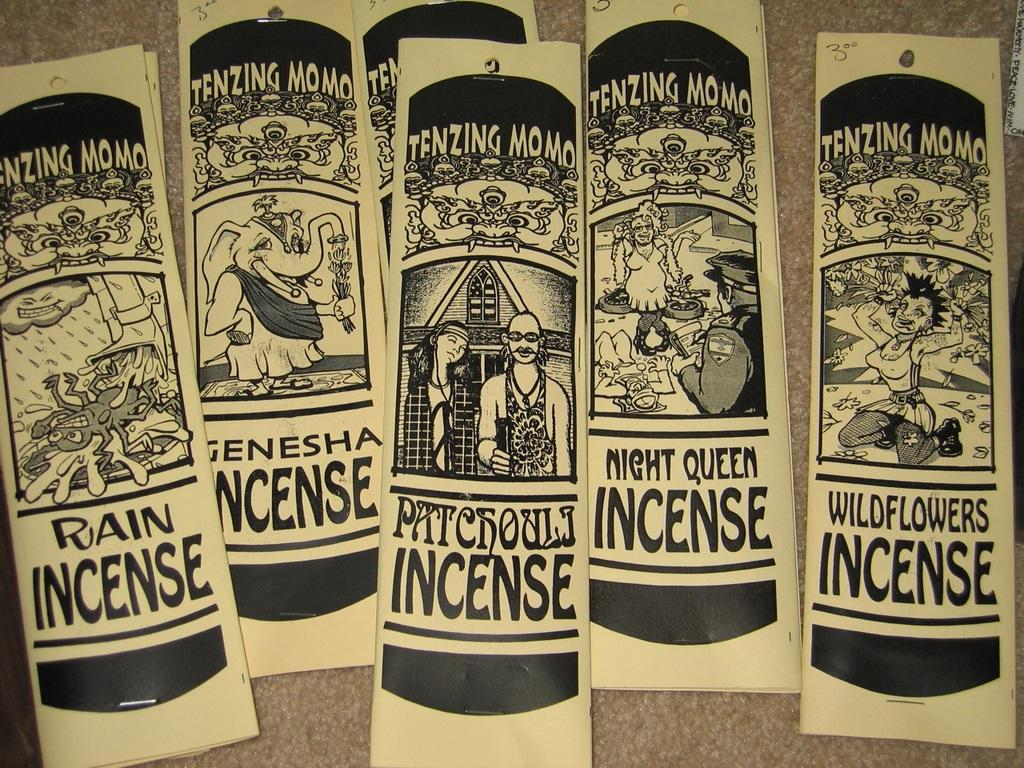What type of content is depicted in the image? There are comics in the image. What is the color of the surface on which the comics are placed? The comics are on a brown surface. What can be found within the comics? There are images and text written in the comics. How many babies are visible in the image? There are no babies present in the image; it features comics with images and text. What is the color of the moon in the image? There is no moon present in the image; it features comics with images and text. 